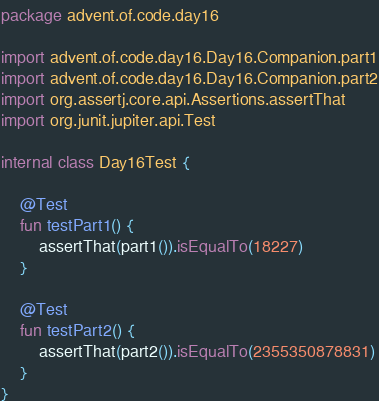<code> <loc_0><loc_0><loc_500><loc_500><_Kotlin_>package advent.of.code.day16

import advent.of.code.day16.Day16.Companion.part1
import advent.of.code.day16.Day16.Companion.part2
import org.assertj.core.api.Assertions.assertThat
import org.junit.jupiter.api.Test

internal class Day16Test {

    @Test
    fun testPart1() {
        assertThat(part1()).isEqualTo(18227)
    }

    @Test
    fun testPart2() {
        assertThat(part2()).isEqualTo(2355350878831)
    }
}
</code> 